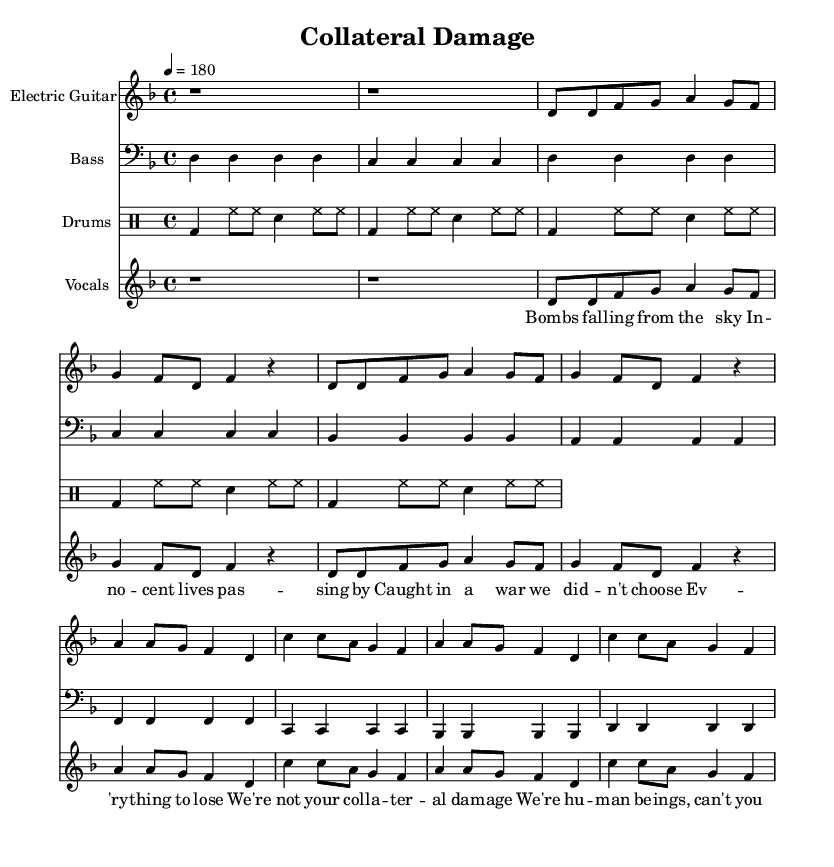What is the key signature of this music? The key signature is D minor, which includes one flat (B flat). This is indicated by the key signature at the beginning of the staff.
Answer: D minor What is the time signature of this piece? The time signature is 4/4, which is shown at the beginning of the music sheet. This means there are four beats in a measure and the quarter note gets one beat.
Answer: 4/4 What is the tempo marking for this piece? The tempo marking is indicated as 4 = 180, meaning there should be 180 beats per minute, which is a fast tempo typical for punk music.
Answer: 180 How many measures are in the chorus section? The chorus contains 4 measures, which can be counted visually in the corresponding section of the sheet music. Each line of lyrics represents a new measure.
Answer: 4 What instrument plays the main melody in this song? The main melody is played by the Electric Guitar, as indicated by the instrument name in the staff at the top.
Answer: Electric Guitar How do the bass and drums contribute to the punk sound in this piece? The bass plays steady rhythmic notes in sync with the drums, emphasizing the aggressive style typical of punk music. The drums use a consistent beat pattern throughout, reinforcing the driving energy. This combination creates a powerful foundation for the vocals and guitars to express the song's message.
Answer: Steady rhythmic foundation 